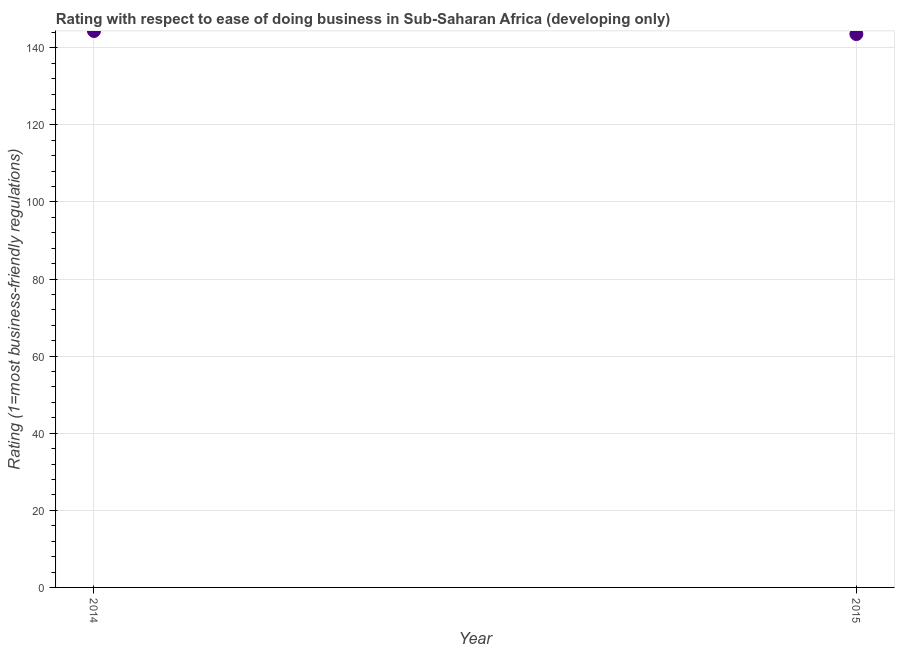What is the ease of doing business index in 2015?
Ensure brevity in your answer.  143.56. Across all years, what is the maximum ease of doing business index?
Ensure brevity in your answer.  144.36. Across all years, what is the minimum ease of doing business index?
Provide a short and direct response. 143.56. In which year was the ease of doing business index maximum?
Ensure brevity in your answer.  2014. In which year was the ease of doing business index minimum?
Give a very brief answer. 2015. What is the sum of the ease of doing business index?
Give a very brief answer. 287.91. What is the difference between the ease of doing business index in 2014 and 2015?
Ensure brevity in your answer.  0.8. What is the average ease of doing business index per year?
Your response must be concise. 143.96. What is the median ease of doing business index?
Offer a very short reply. 143.96. What is the ratio of the ease of doing business index in 2014 to that in 2015?
Provide a short and direct response. 1.01. Is the ease of doing business index in 2014 less than that in 2015?
Provide a short and direct response. No. How many dotlines are there?
Provide a short and direct response. 1. Are the values on the major ticks of Y-axis written in scientific E-notation?
Keep it short and to the point. No. Does the graph contain any zero values?
Your answer should be compact. No. What is the title of the graph?
Ensure brevity in your answer.  Rating with respect to ease of doing business in Sub-Saharan Africa (developing only). What is the label or title of the Y-axis?
Offer a very short reply. Rating (1=most business-friendly regulations). What is the Rating (1=most business-friendly regulations) in 2014?
Your answer should be very brief. 144.36. What is the Rating (1=most business-friendly regulations) in 2015?
Provide a short and direct response. 143.56. What is the ratio of the Rating (1=most business-friendly regulations) in 2014 to that in 2015?
Your response must be concise. 1.01. 